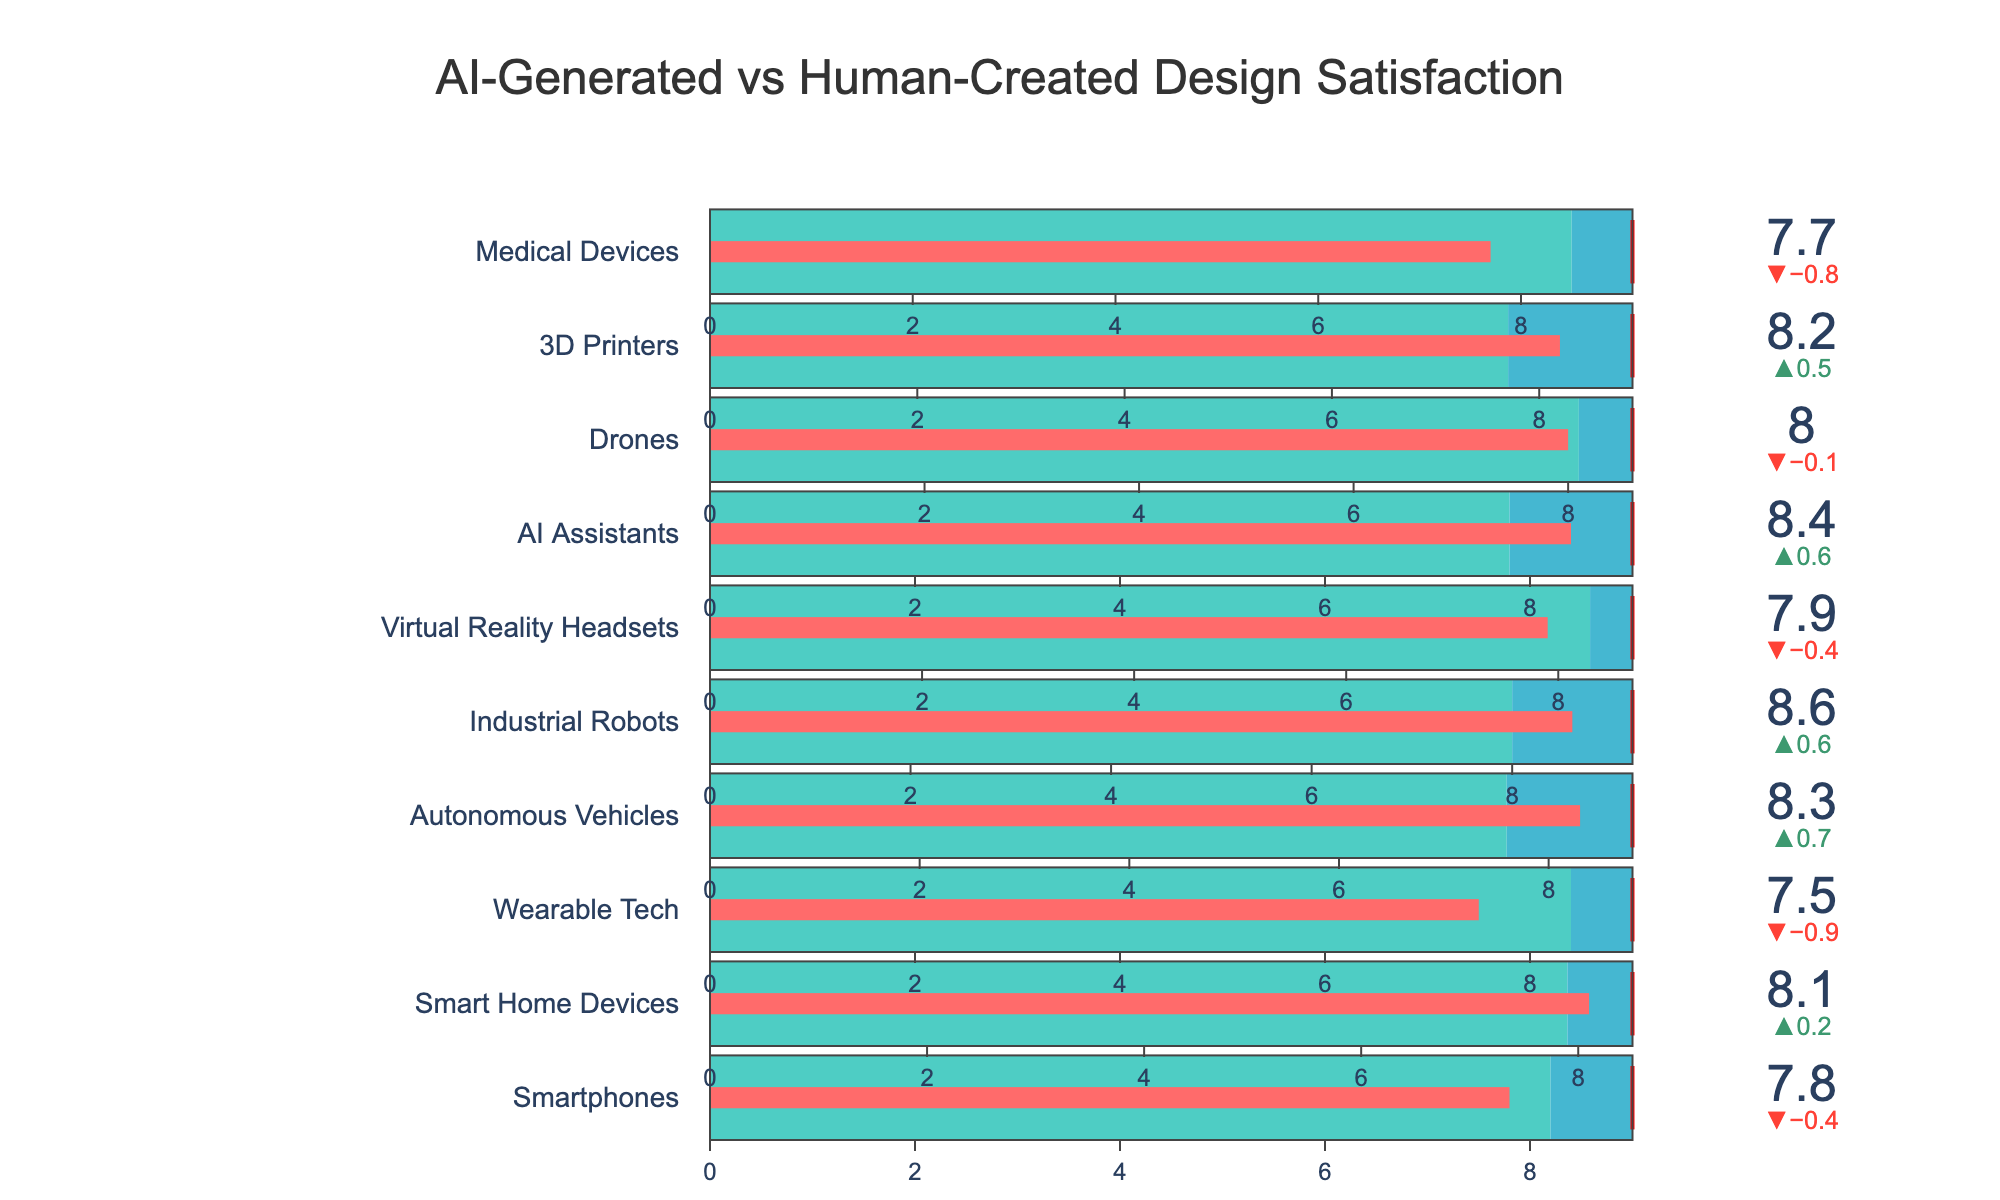How many product types are shown in the chart? Count each product type listed in the figure. There are 10 product types: Smartphones, Smart Home Devices, Wearable Tech, Autonomous Vehicles, Industrial Robots, Virtual Reality Headsets, AI Assistants, Drones, 3D Printers, and Medical Devices.
Answer: 10 Which product type has the highest AI-Generated Design Satisfaction? Look at the values of AI-Generated Design Satisfaction for all product types; Industrial Robots have the highest satisfaction score of 8.6.
Answer: Industrial Robots What is the difference in satisfaction between AI-Generated and Human-Created designs for Wearable Tech? Subtract the Human-Created Design Satisfaction (8.4) from the AI-Generated Design Satisfaction (7.5): 7.5 - 8.4 = -0.9.
Answer: -0.9 For which product types is AI-Generated Design Satisfaction greater than Human-Created Design Satisfaction? Compare the satisfaction scores of AI-Generated and Human-Created designs for each product type. The results are: Smart Home Devices, Autonomous Vehicles, Industrial Robots, AI Assistants, and 3D Printers.
Answer: Smart Home Devices, Autonomous Vehicles, Industrial Robots, AI Assistants, 3D Printers What is the average satisfaction score for Human-Created designs across all product types? Add all Human-Created Design Satisfaction scores and divide by the number of product types: (8.2 + 7.9 + 8.4 + 7.6 + 8.0 + 8.3 + 7.8 + 8.1 + 7.7 + 8.5) / 10 = 8.05.
Answer: 8.05 What is the title of the chart? The title is displayed at the top of the chart: "AI-Generated vs Human-Created Design Satisfaction".
Answer: AI-Generated vs Human-Created Design Satisfaction Which product type has a Target Satisfaction that the AI-Generated Design Satisfaction exceeds? Compare AI-Generated Design Satisfaction with Target Satisfaction for each product type; none of the AI-Generated Design scores exceed their respective Target Satisfaction.
Answer: None Is the satisfaction for AI-Generated designs always less than the Target Satisfaction? Compare each AI-Generated Design Satisfaction value to its corresponding Target Satisfaction. All AI-Generated values are lower than their Target Satisfaction.
Answer: Yes Among Drones and AI Assistants, which has a higher Human-Created Design Satisfaction? Compare the Human-Created Design Satisfaction scores for Drones (8.1) and AI Assistants (7.8). Drones have higher satisfaction.
Answer: Drones What color represents the AI-Generated Design Satisfaction in the bullet chart? Identify the color used for AI-Generated Design Satisfaction, which is shown by the bar color in the bullet chart. It is represented by red.
Answer: Red 